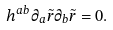Convert formula to latex. <formula><loc_0><loc_0><loc_500><loc_500>h ^ { a b } \partial _ { a } \tilde { r } \partial _ { b } \tilde { r } = 0 .</formula> 